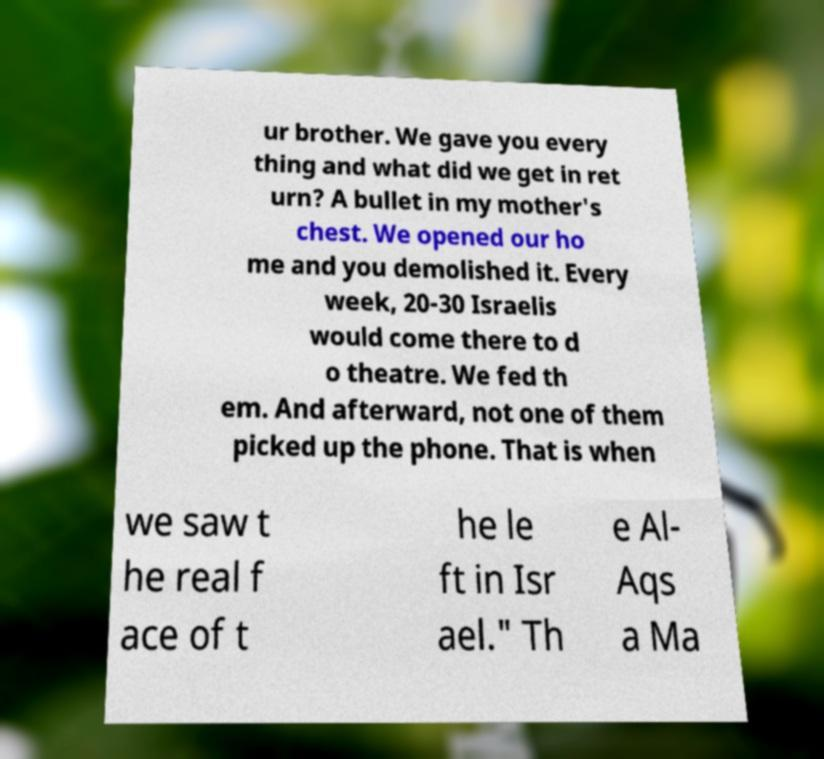Can you accurately transcribe the text from the provided image for me? ur brother. We gave you every thing and what did we get in ret urn? A bullet in my mother's chest. We opened our ho me and you demolished it. Every week, 20-30 Israelis would come there to d o theatre. We fed th em. And afterward, not one of them picked up the phone. That is when we saw t he real f ace of t he le ft in Isr ael." Th e Al- Aqs a Ma 